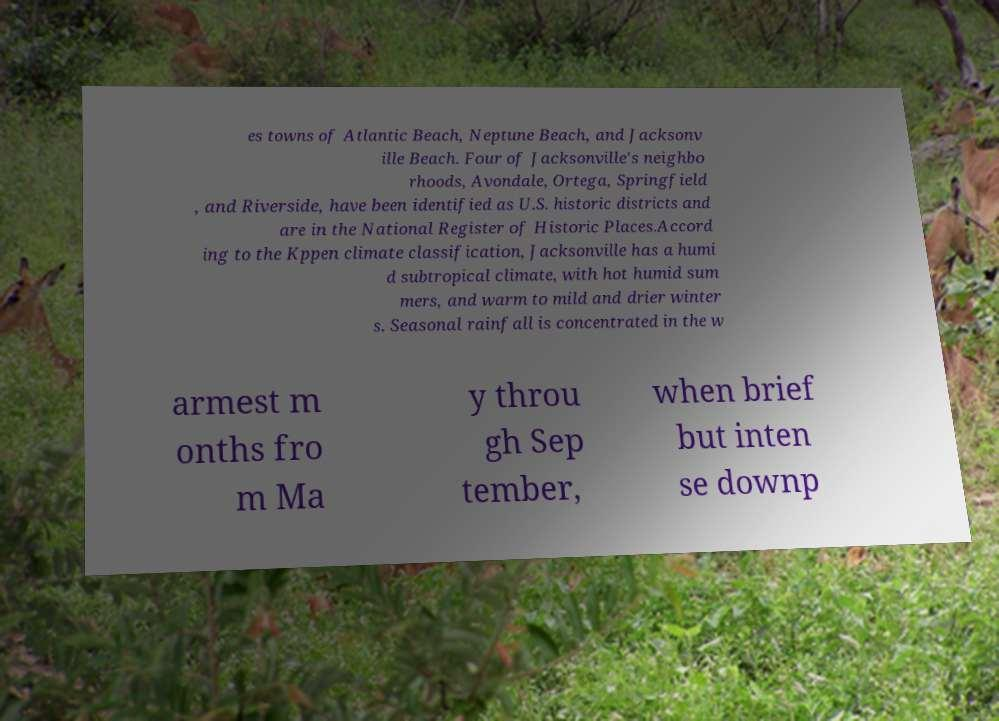Please read and relay the text visible in this image. What does it say? es towns of Atlantic Beach, Neptune Beach, and Jacksonv ille Beach. Four of Jacksonville's neighbo rhoods, Avondale, Ortega, Springfield , and Riverside, have been identified as U.S. historic districts and are in the National Register of Historic Places.Accord ing to the Kppen climate classification, Jacksonville has a humi d subtropical climate, with hot humid sum mers, and warm to mild and drier winter s. Seasonal rainfall is concentrated in the w armest m onths fro m Ma y throu gh Sep tember, when brief but inten se downp 